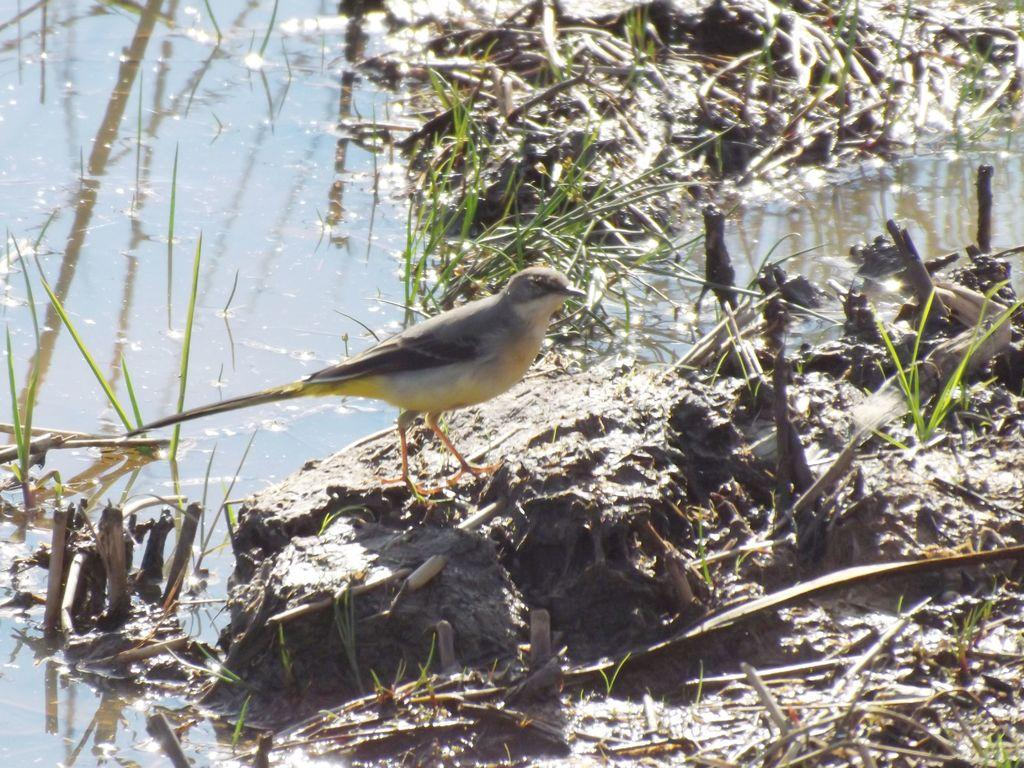What type of animal can be seen in the image? There is a bird in the image. Where is the bird located? The bird is standing on a rock. What type of vegetation is present in the image? There is grass in the image. What else can be seen in the image besides the bird and grass? There is water visible in the image. What type of bell is hanging from the bird's neck in the image? There is no bell present in the image; the bird is not wearing any accessories. 